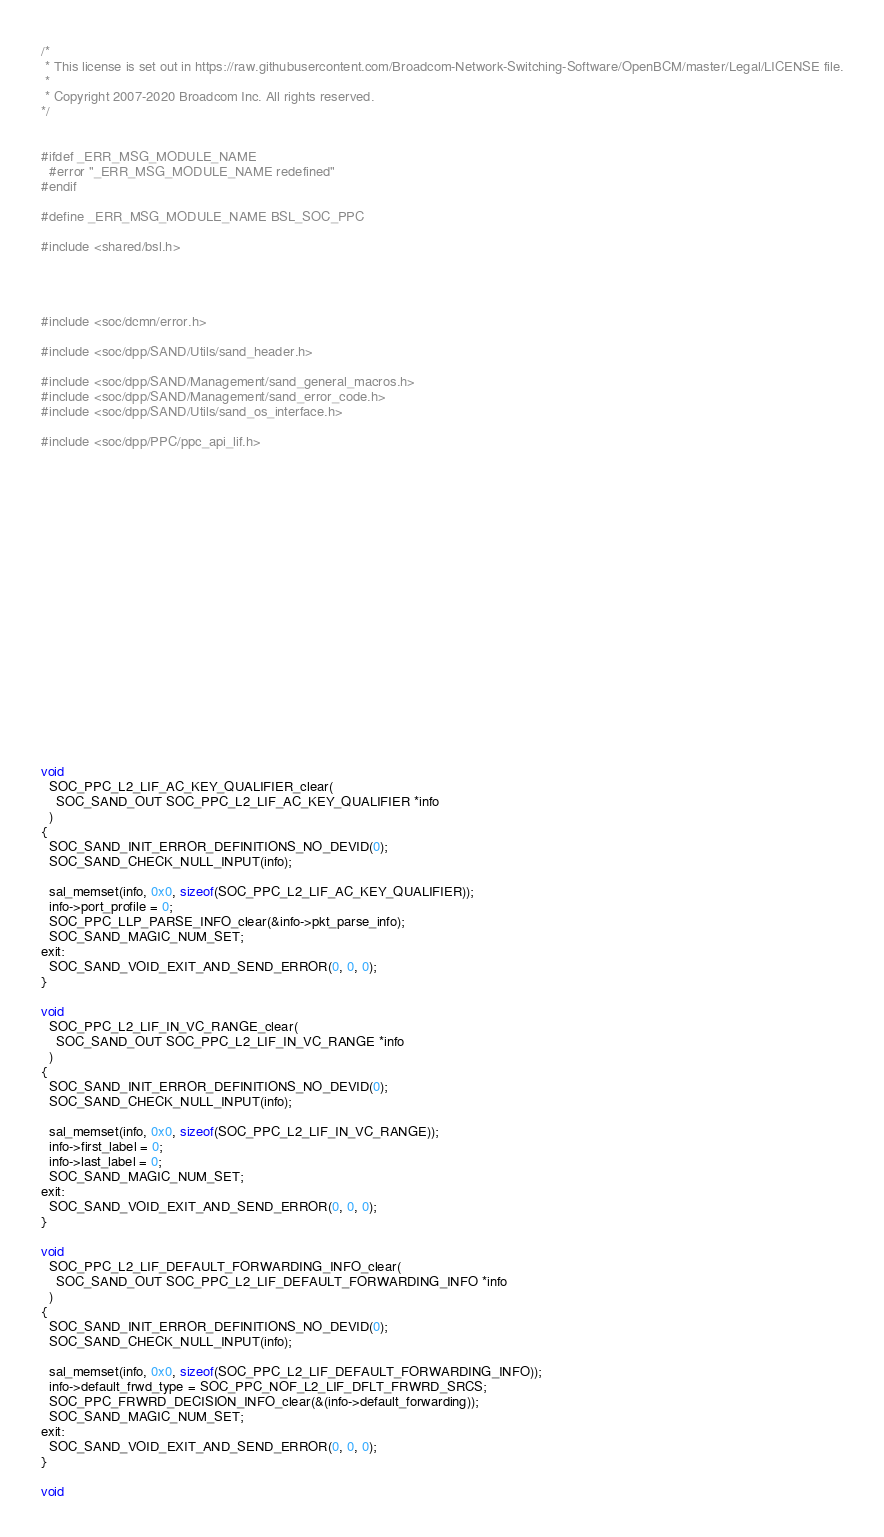<code> <loc_0><loc_0><loc_500><loc_500><_C_>/* 
 * This license is set out in https://raw.githubusercontent.com/Broadcom-Network-Switching-Software/OpenBCM/master/Legal/LICENSE file.
 * 
 * Copyright 2007-2020 Broadcom Inc. All rights reserved.
*/


#ifdef _ERR_MSG_MODULE_NAME
  #error "_ERR_MSG_MODULE_NAME redefined"
#endif

#define _ERR_MSG_MODULE_NAME BSL_SOC_PPC

#include <shared/bsl.h>




#include <soc/dcmn/error.h>

#include <soc/dpp/SAND/Utils/sand_header.h>

#include <soc/dpp/SAND/Management/sand_general_macros.h>
#include <soc/dpp/SAND/Management/sand_error_code.h>
#include <soc/dpp/SAND/Utils/sand_os_interface.h>

#include <soc/dpp/PPC/ppc_api_lif.h>





















void
  SOC_PPC_L2_LIF_AC_KEY_QUALIFIER_clear(
    SOC_SAND_OUT SOC_PPC_L2_LIF_AC_KEY_QUALIFIER *info
  )
{
  SOC_SAND_INIT_ERROR_DEFINITIONS_NO_DEVID(0);
  SOC_SAND_CHECK_NULL_INPUT(info);

  sal_memset(info, 0x0, sizeof(SOC_PPC_L2_LIF_AC_KEY_QUALIFIER));
  info->port_profile = 0;
  SOC_PPC_LLP_PARSE_INFO_clear(&info->pkt_parse_info);
  SOC_SAND_MAGIC_NUM_SET;
exit:
  SOC_SAND_VOID_EXIT_AND_SEND_ERROR(0, 0, 0);
}

void
  SOC_PPC_L2_LIF_IN_VC_RANGE_clear(
    SOC_SAND_OUT SOC_PPC_L2_LIF_IN_VC_RANGE *info
  )
{
  SOC_SAND_INIT_ERROR_DEFINITIONS_NO_DEVID(0);
  SOC_SAND_CHECK_NULL_INPUT(info);

  sal_memset(info, 0x0, sizeof(SOC_PPC_L2_LIF_IN_VC_RANGE));
  info->first_label = 0;
  info->last_label = 0;
  SOC_SAND_MAGIC_NUM_SET;
exit:
  SOC_SAND_VOID_EXIT_AND_SEND_ERROR(0, 0, 0);
}

void
  SOC_PPC_L2_LIF_DEFAULT_FORWARDING_INFO_clear(
    SOC_SAND_OUT SOC_PPC_L2_LIF_DEFAULT_FORWARDING_INFO *info
  )
{
  SOC_SAND_INIT_ERROR_DEFINITIONS_NO_DEVID(0);
  SOC_SAND_CHECK_NULL_INPUT(info);

  sal_memset(info, 0x0, sizeof(SOC_PPC_L2_LIF_DEFAULT_FORWARDING_INFO));
  info->default_frwd_type = SOC_PPC_NOF_L2_LIF_DFLT_FRWRD_SRCS;
  SOC_PPC_FRWRD_DECISION_INFO_clear(&(info->default_forwarding));
  SOC_SAND_MAGIC_NUM_SET;
exit:
  SOC_SAND_VOID_EXIT_AND_SEND_ERROR(0, 0, 0);
}

void</code> 